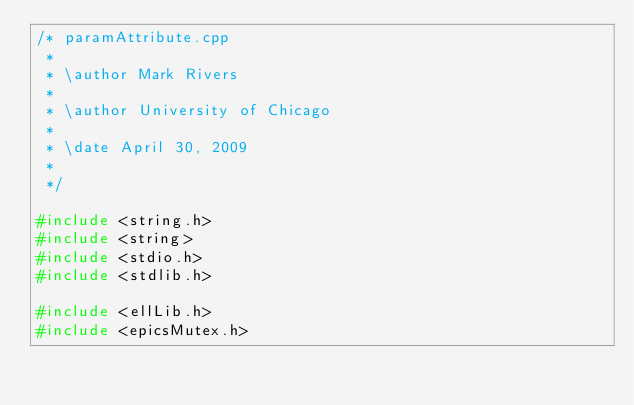<code> <loc_0><loc_0><loc_500><loc_500><_C++_>/* paramAttribute.cpp
 *
 * \author Mark Rivers
 *
 * \author University of Chicago
 *
 * \date April 30, 2009
 *
 */

#include <string.h>
#include <string>
#include <stdio.h>
#include <stdlib.h>

#include <ellLib.h>
#include <epicsMutex.h></code> 